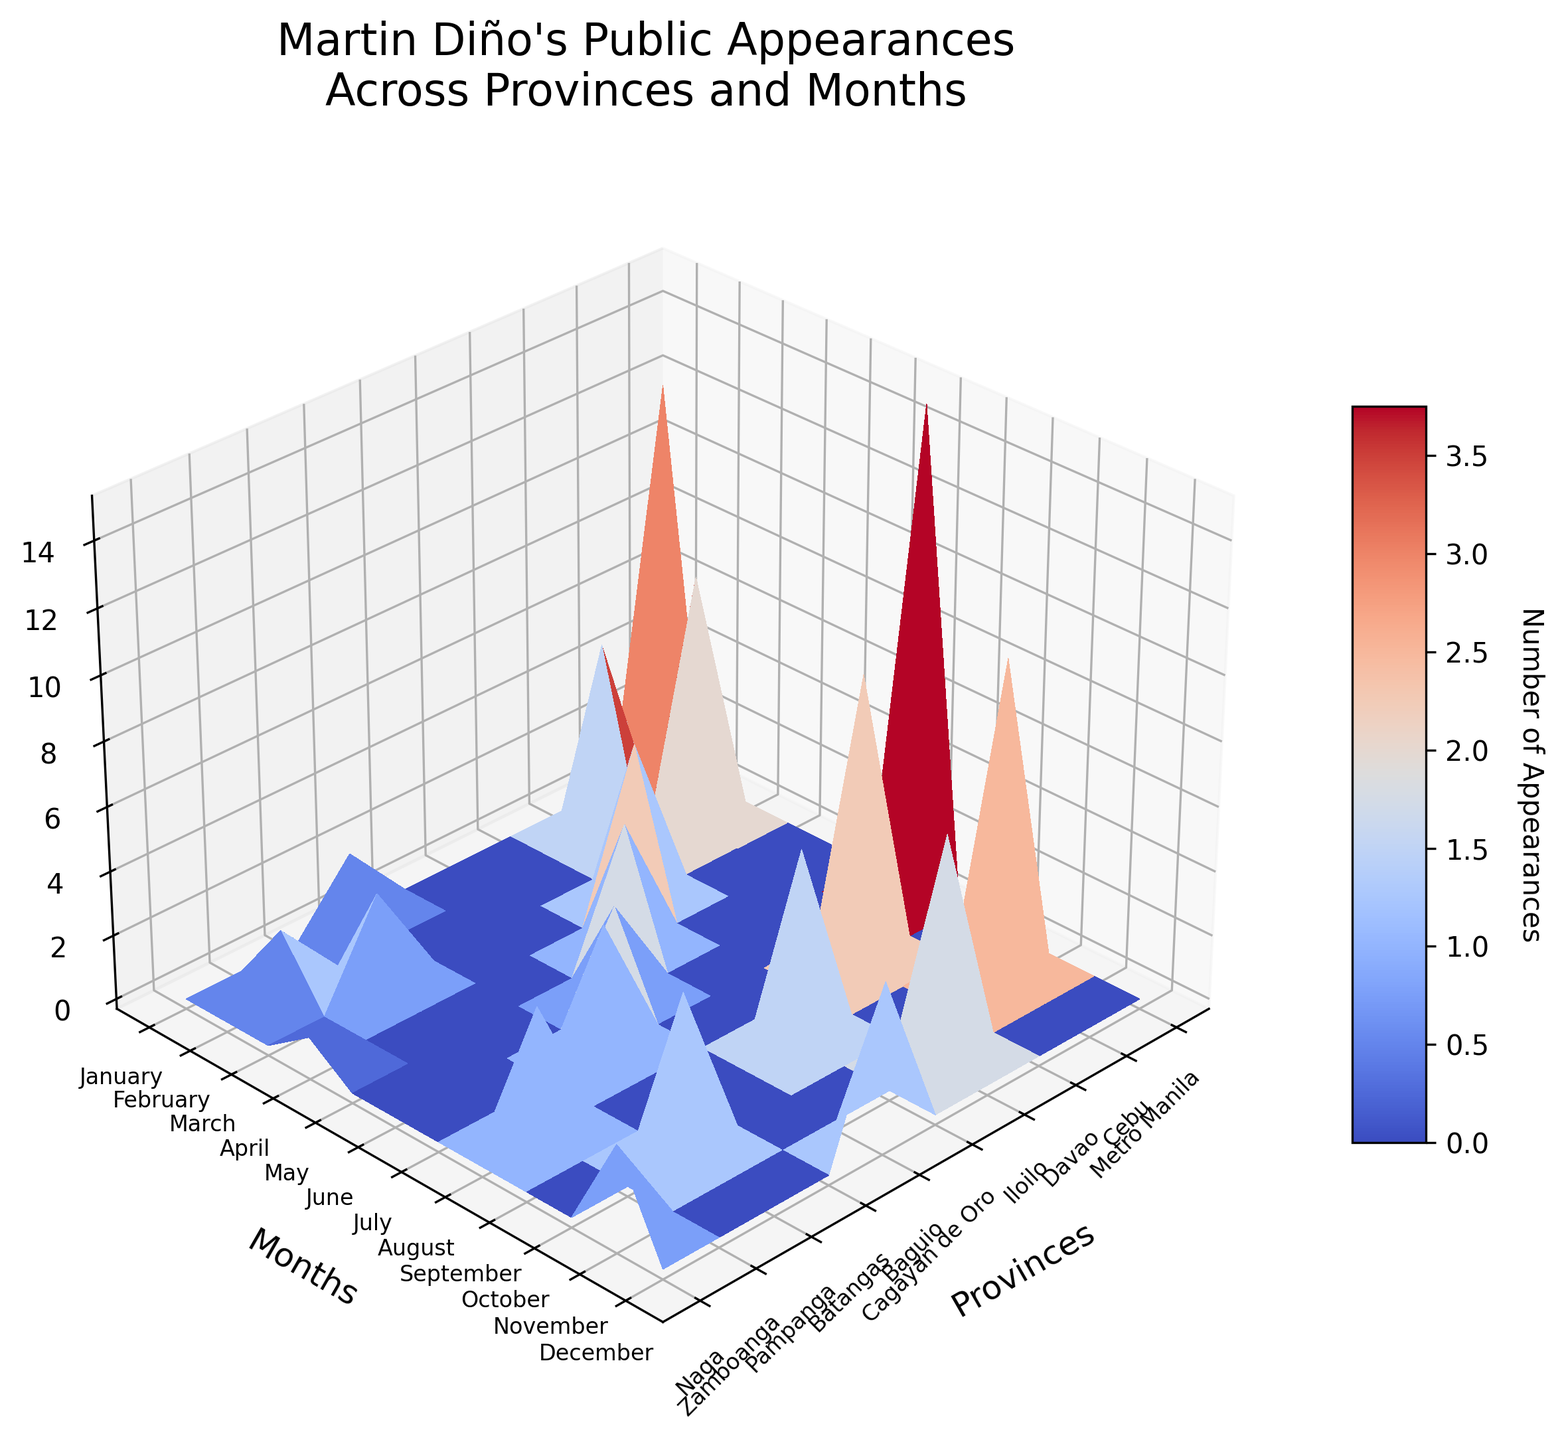What's the title of the figure? The title of the figure is displayed at the top and summarizes what the plot depicts. In this case, it likely mentions Martin Diño's public appearances across provinces and months.
Answer: Martin Diño's Public Appearances Across Provinces and Months What's the label for the x-axis? The x-axis label describes what dimension is represented along the x-axis, which in this figure is the provinces where Martin Diño made public appearances.
Answer: Provinces Which month has the highest number of appearances in Metro Manila? Locate the province 'Metro Manila' on the x-axis, then look for the highest peak in the Z-axis (appearances) within the range corresponding to months. The highest number can be visually identified as the tallest point.
Answer: July In which province and month did Martin Diño have the least public appearances? Identify the shortest point on the z-axis (appearances). Track this point along the x-axis (provinces) and y-axis (months) to determine the exact province and month.
Answer: Naga, April Compare appearances between Cebu and Davao in October. Which showed higher engagement? Locate the positions of Cebu and Davao on the x-axis. Then, move vertically to find the point corresponding to October on the y-axis. Compare the z-axis values for these two points to see which is higher.
Answer: Cebu How many provinces did Martin Diño visit more than once in January? Locate January on the y-axis. Count the number of provinces on the x-axis that have a z value (appearances) greater than one for January.
Answer: 2 What's the range of appearances (difference between highest and lowest appearance counts) in Baguio? Find the points representing Baguio on the x-axis, then observe the peaks and troughs along the z-axis for appearances. Subtract the lowest number of appearances from the highest. For Baguio, the highest is in December (5) and lowest in June (3).
Answer: 2 Which province saw an increase in the number of appearances from February to August? Track the z-axis values of appearances from February to August for each province and identify which province shows a growth in these values over time. For example, Davao in February (6) and August (9).
Answer: Davao What is the total number of appearances in Iloilo over the months displayed? Sum the z-axis values across all months for the province of Iloilo. The appearances in April and November are 5 and 7, respectively.
Answer: 12 Are there more appearances in Metro Manila during July or Cebu during October? Compare the z-axis values for these specific data points. Locate July for Metro Manila and October for Cebu, then compare their heights.
Answer: Metro Manila in July (15) 